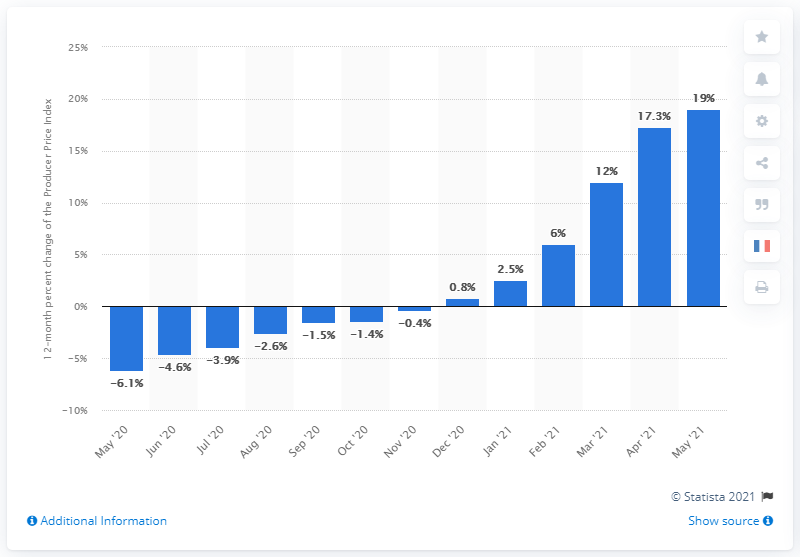Specify some key components in this picture. The Producer Price Index (PPI) for commodities increased by 19% in May 2021 compared to May 2020. 